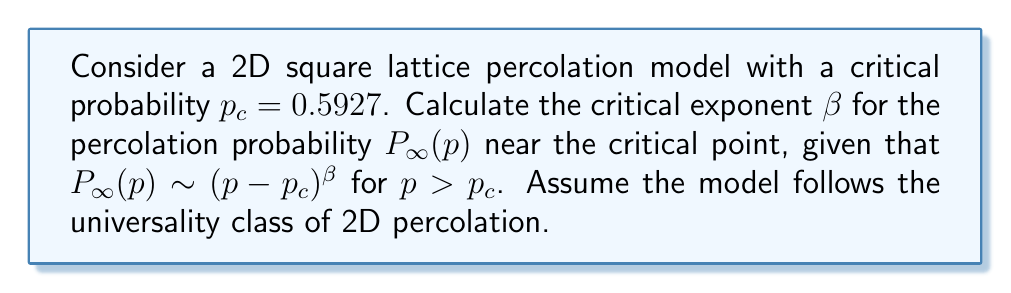Can you solve this math problem? To determine the critical exponent $\beta$ for the 2D square lattice percolation model, we follow these steps:

1) The universality hypothesis states that critical exponents are independent of the microscopic details of the system and depend only on the dimensionality and symmetry of the problem.

2) For 2D percolation, the exact value of $\beta$ is known to be $\beta = \frac{5}{36}$.

3) This value can be derived using conformal field theory or through numerical simulations.

4) The exponent $\beta$ describes how the percolation probability $P_\infty(p)$ scales near the critical point:

   $$P_\infty(p) \sim (p - p_c)^\beta$$

5) This scaling behavior is universal for all 2D lattice percolation models, including the square lattice.

6) The critical probability $p_c = 0.5927$ given in the problem is specific to the square lattice, but it does not affect the value of $\beta$.

7) Therefore, for this 2D square lattice percolation model, we can directly use the universal value $\beta = \frac{5}{36}$.
Answer: $\beta = \frac{5}{36}$ 